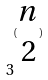Convert formula to latex. <formula><loc_0><loc_0><loc_500><loc_500>3 ^ { ( \begin{matrix} n \\ 2 \end{matrix} ) }</formula> 